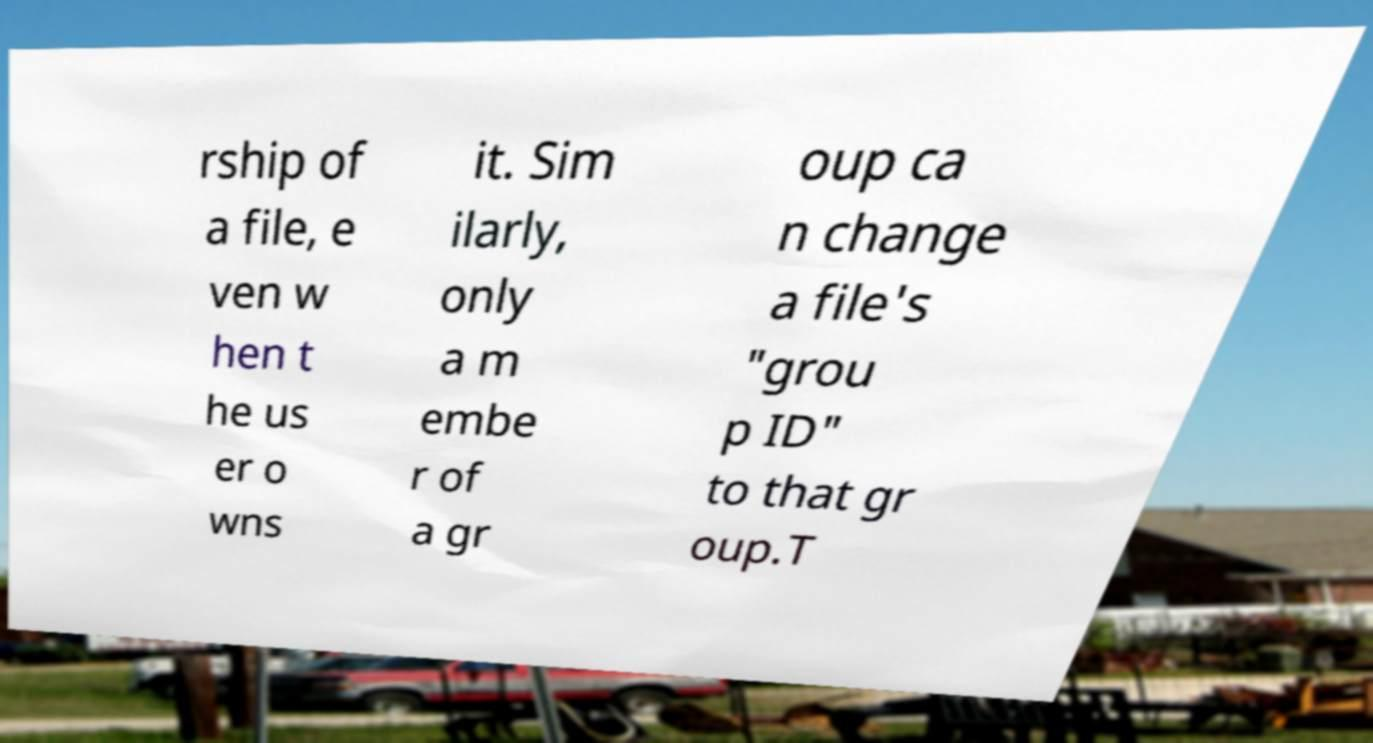For documentation purposes, I need the text within this image transcribed. Could you provide that? rship of a file, e ven w hen t he us er o wns it. Sim ilarly, only a m embe r of a gr oup ca n change a file's "grou p ID" to that gr oup.T 